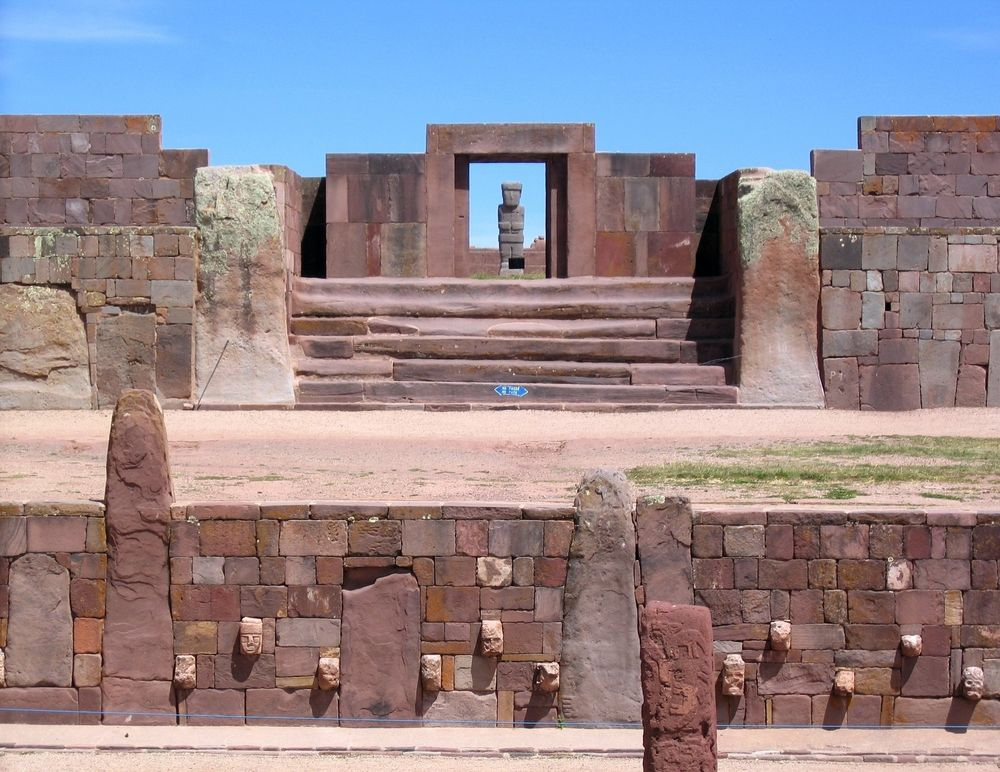Write a detailed description of the given image. The image showcases the grandeur of the Tiwanaku ruins in Bolivia, a historical site of immense archaeological significance. Central to the photograph is a prominent stone structure, meticulously crafted from reddish-brown stones with an intricate arrangement that reflects the architectural prowess of the ancient Tiwanaku civilization. The focal point is a central staircase that seemingly invites the observer to ascend towards a doorway, which stands as a symbolic portal to a time long past. The left side of the structure features noticeable green stones, providing a refreshing contrast to the otherwise subdued color scheme. The ground, a harmonious reddish-brown, complements the structure, enhancing the aesthetic balance. The backdrop is a brilliantly clear blue sky, adding a vibrant dimension to the scene. The photograph's perspective from the front draws the viewer’s eyes upward along the staircase to the doorway, evoking a sense of embarking on a historical journey. This image compellingly illustrates the enduring legacy and stone-working mastery of the Tiwanaku civilization. 